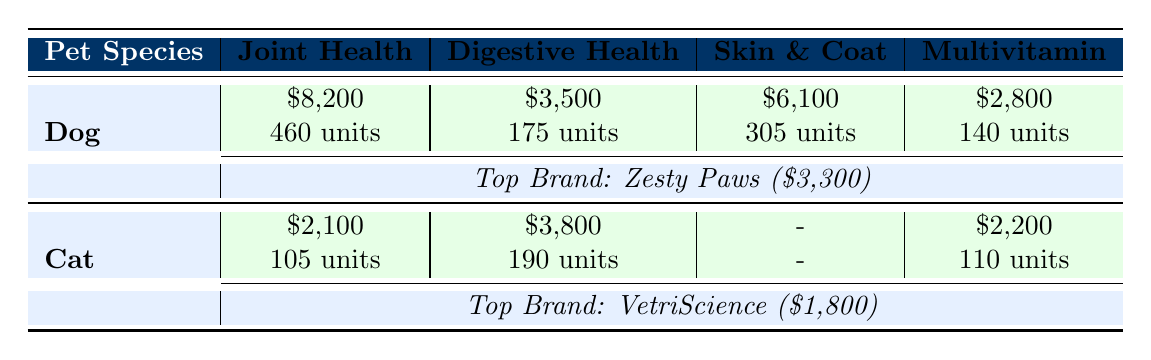What are the total sales for Dog Joint Health supplements? The table indicates that there are two entries for Dog Joint Health supplements. The total sales for Dog Joint Health is calculated by summing the values: $8,200 from the first row.
Answer: 8200 What is the top-selling brand for Cat Digestive Health supplements? The table shows that for Cat Digestive Health, the best-selling brand is VetriScience with a sales value of $1,800.
Answer: VetriScience How many units of Dog Skin & Coat supplements were sold? From the table, 305 units of Dog Skin & Coat supplements are listed under the respective category.
Answer: 305 What is the total sales amount for Cat supplements? To find the total sales for Cat supplements, I will sum the sales from the Cat rows: $2,100 (Joint Health) + $3,800 (Digestive Health) + $2,200 (Multivitamin) = $8,100.
Answer: 8100 Is there a Skin & Coat supplement for Cats? The table indicates that there are no entries listed for Cat Skin & Coat supplements. Therefore, the answer is no.
Answer: No What is the average sales amount for Dog supplements? To calculate the average, first determine the total sales for all Dog supplements: $8,200 (Joint Health) + $3,500 (Digestive Health) + $6,100 (Skin & Coat) + $2,800 (Multivitamin) = $20,600. There are four entries, so the average is $20,600 divided by 4, which equals $5,150.
Answer: 5150 How many units were sold for the Joint Health supplements across both species? The total units sold for Joint Health supplements are found by adding Dog units (460) and Cat units (105). Therefore, 460 + 105 equals 565 total units sold.
Answer: 565 What is the difference in sales between Dog and Cat Multivitamin supplements? From the table, Dog Multivitamin sales are $2,800 and Cat Multivitamin sales are $2,200. The difference is calculated as $2,800 - $2,200, which equals $600.
Answer: 600 